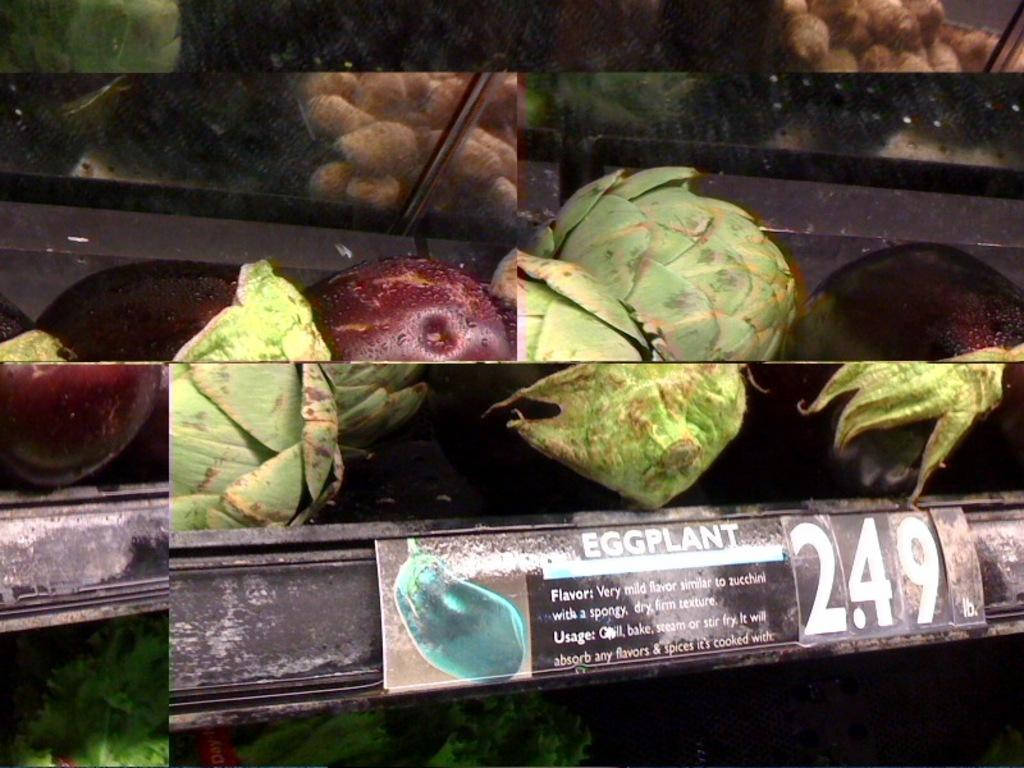What type of food items can be seen in the image? There are vegetables in the image. Is there any indication of the cost of the vegetables in the image? Yes, there is a price tag in the image. What additional information might be available to customers in the image? There is an information board in the image. How many children are playing with the leather monkey in the image? There are no children or monkeys present in the image; it only features vegetables, a price tag, and an information board. 